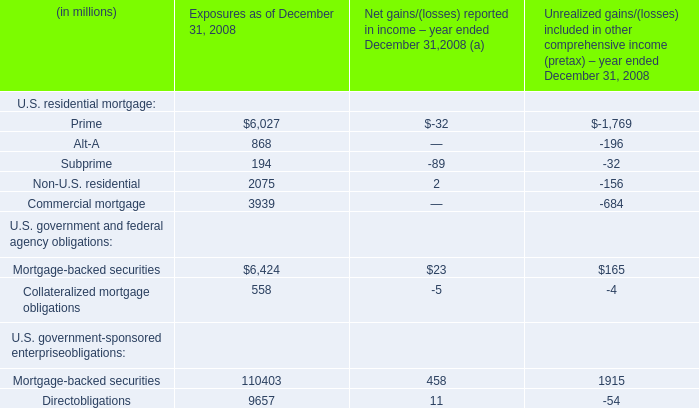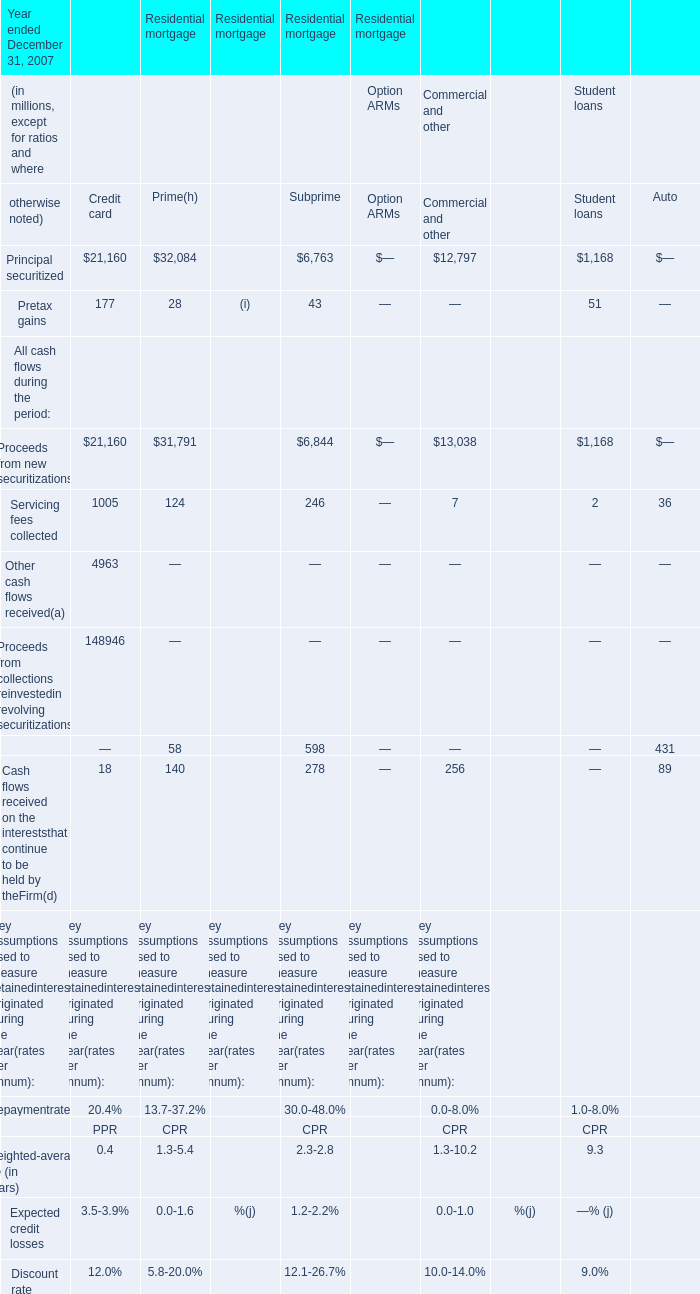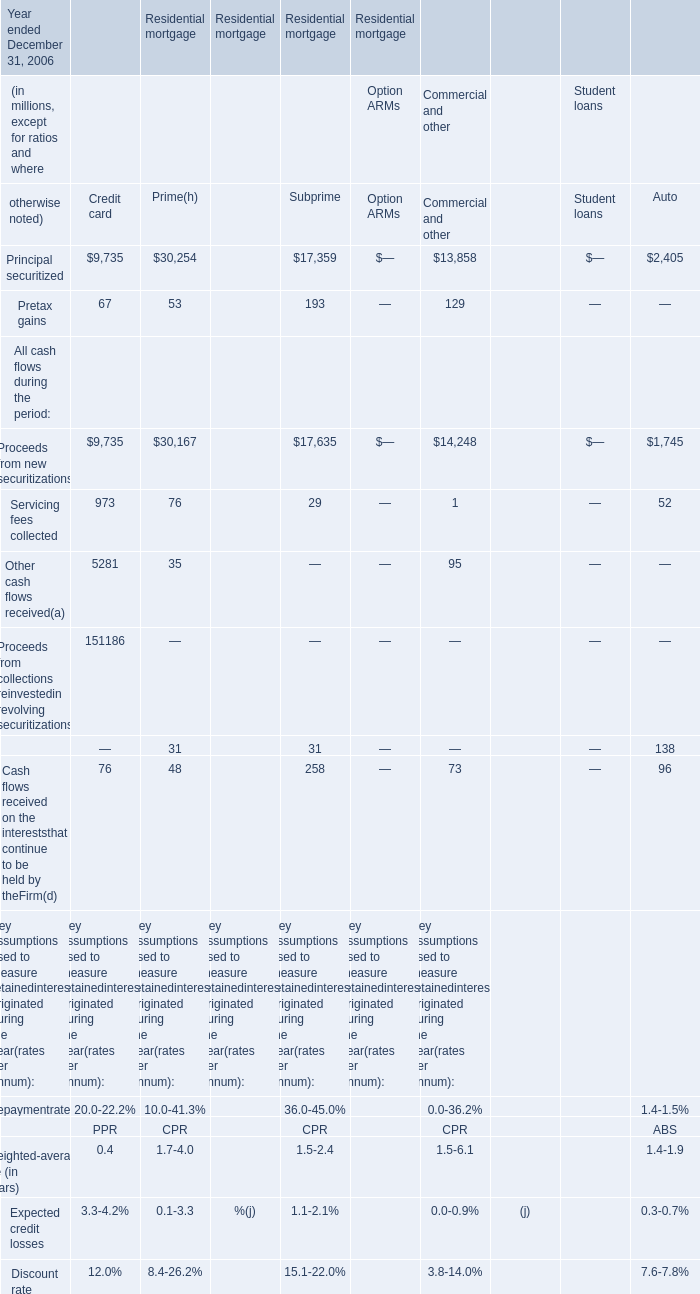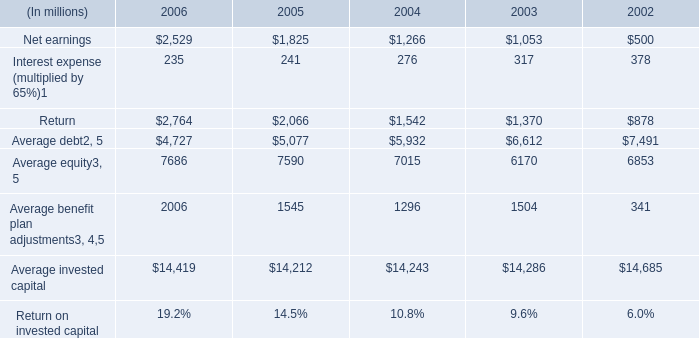What is the sum of Principal securitized of Residential mortgage Commercial and other, Average invested capital of 2002, and Average equity of 2004 ? 
Computations: ((13858.0 + 14685.0) + 7015.0)
Answer: 35558.0. 